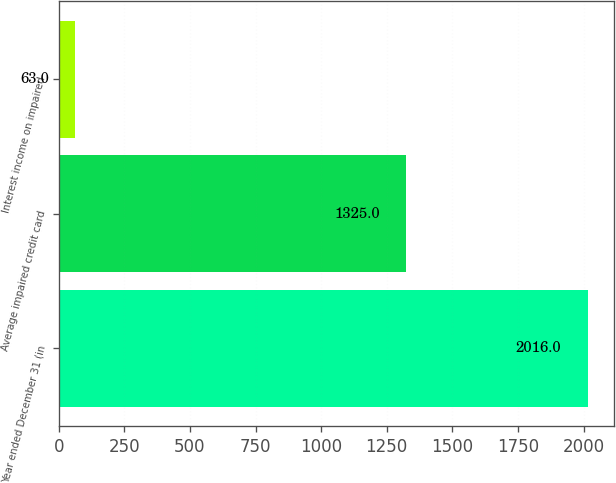Convert chart. <chart><loc_0><loc_0><loc_500><loc_500><bar_chart><fcel>Year ended December 31 (in<fcel>Average impaired credit card<fcel>Interest income on impaired<nl><fcel>2016<fcel>1325<fcel>63<nl></chart> 